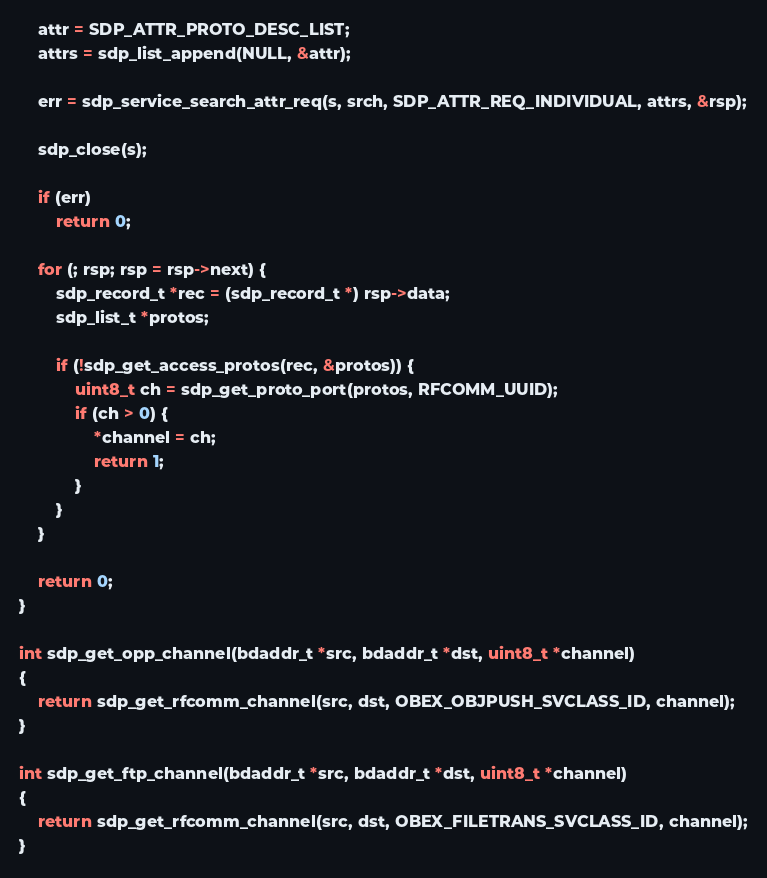Convert code to text. <code><loc_0><loc_0><loc_500><loc_500><_C_>	attr = SDP_ATTR_PROTO_DESC_LIST;
	attrs = sdp_list_append(NULL, &attr);

	err = sdp_service_search_attr_req(s, srch, SDP_ATTR_REQ_INDIVIDUAL, attrs, &rsp);

	sdp_close(s);
	
	if (err)
		return 0;

	for (; rsp; rsp = rsp->next) {
		sdp_record_t *rec = (sdp_record_t *) rsp->data;
		sdp_list_t *protos;

		if (!sdp_get_access_protos(rec, &protos)) {
			uint8_t ch = sdp_get_proto_port(protos, RFCOMM_UUID);
			if (ch > 0) {
				*channel = ch;
				return 1;
			}
		}
	}

	return 0;
}

int sdp_get_opp_channel(bdaddr_t *src, bdaddr_t *dst, uint8_t *channel)
{
	return sdp_get_rfcomm_channel(src, dst, OBEX_OBJPUSH_SVCLASS_ID, channel);
}

int sdp_get_ftp_channel(bdaddr_t *src, bdaddr_t *dst, uint8_t *channel)
{
	return sdp_get_rfcomm_channel(src, dst, OBEX_FILETRANS_SVCLASS_ID, channel);
}
</code> 